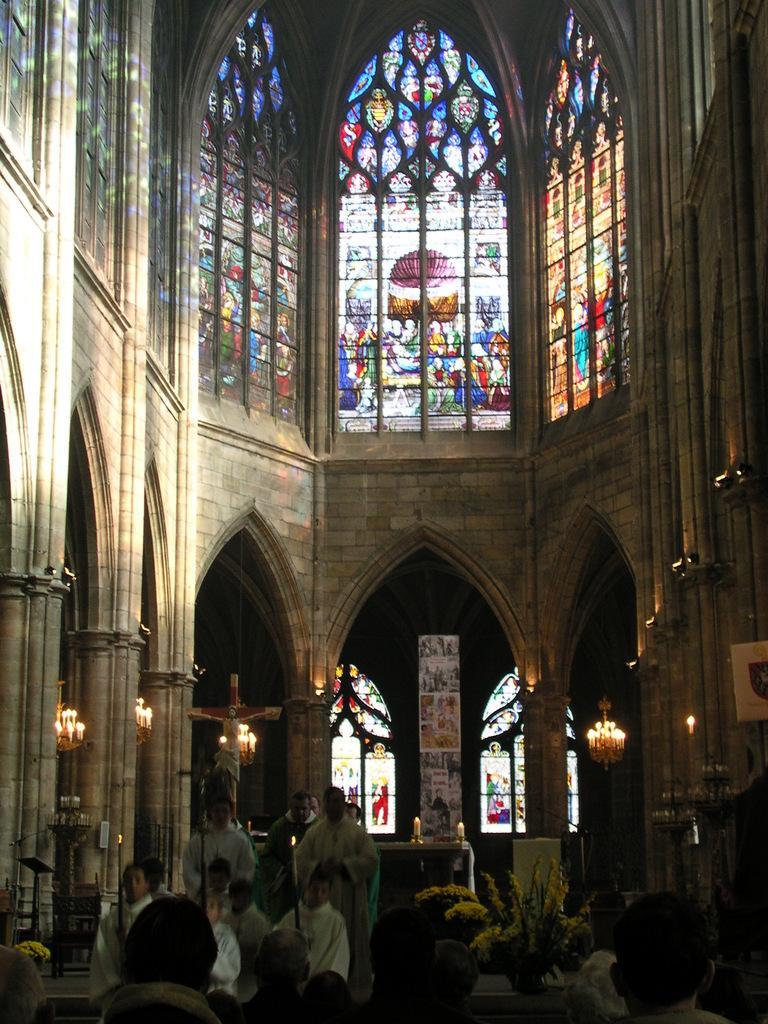Please provide a concise description of this image. In this image we can see an inner view of a church containing the windows, a wall, a statue, pillars, a table, a speaker stand and the chandeliers with some candles on it. On the bottom of the image we can see some people standing. In that some are holding the sticks. We can also see a plant in a pot. 